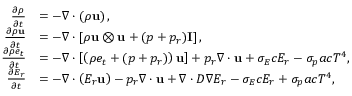<formula> <loc_0><loc_0><loc_500><loc_500>\begin{array} { r l } { \frac { \partial \rho } { \partial t } } & { = - \nabla \cdot \left ( \rho u \right ) , } \\ { \frac { \partial \rho u } { \partial t } } & { = - \nabla \cdot \left [ \rho u \otimes u + ( p + { p _ { r } } ) I \right ] , } \\ { \frac { \partial \rho e _ { t } } { \partial t } } & { = - \nabla \cdot \left [ \left ( \rho e _ { t } + ( p + { p _ { r } } ) \right ) u \right ] + { p _ { r } \nabla \cdot u } + { \sigma _ { E } c E _ { r } } - { \sigma _ { p } a c T ^ { 4 } } , } \\ { \frac { \partial E _ { r } } { \partial t } } & { = - \nabla \cdot \left ( E _ { r } u \right ) - { p _ { r } \nabla \cdot u } + \nabla \cdot D \nabla E _ { r } - { \sigma _ { E } c E _ { r } } + { \sigma _ { p } a c T ^ { 4 } } , } \end{array}</formula> 